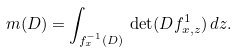Convert formula to latex. <formula><loc_0><loc_0><loc_500><loc_500>m ( D ) = \int _ { f _ { x } ^ { - 1 } ( D ) } \, \det ( D f _ { x , z } ^ { 1 } ) \, d z .</formula> 